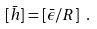<formula> <loc_0><loc_0><loc_500><loc_500>[ \bar { h } ] = [ \bar { \epsilon } / R ] \ .</formula> 